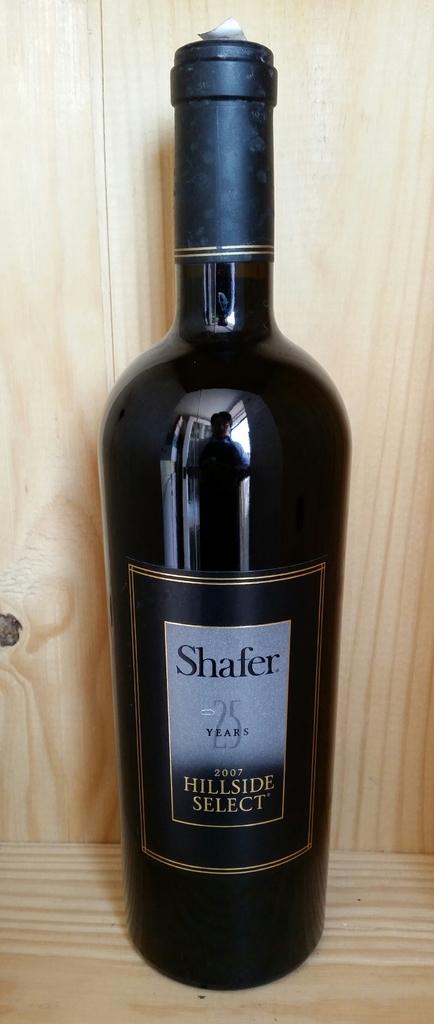What is the name of this wine?
Provide a short and direct response. Shafer. When was this wine made?
Offer a very short reply. 2007. 